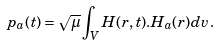<formula> <loc_0><loc_0><loc_500><loc_500>p _ { a } ( t ) = \sqrt { \mu } \int _ { V } H ( r , t ) . H _ { a } ( r ) d v .</formula> 